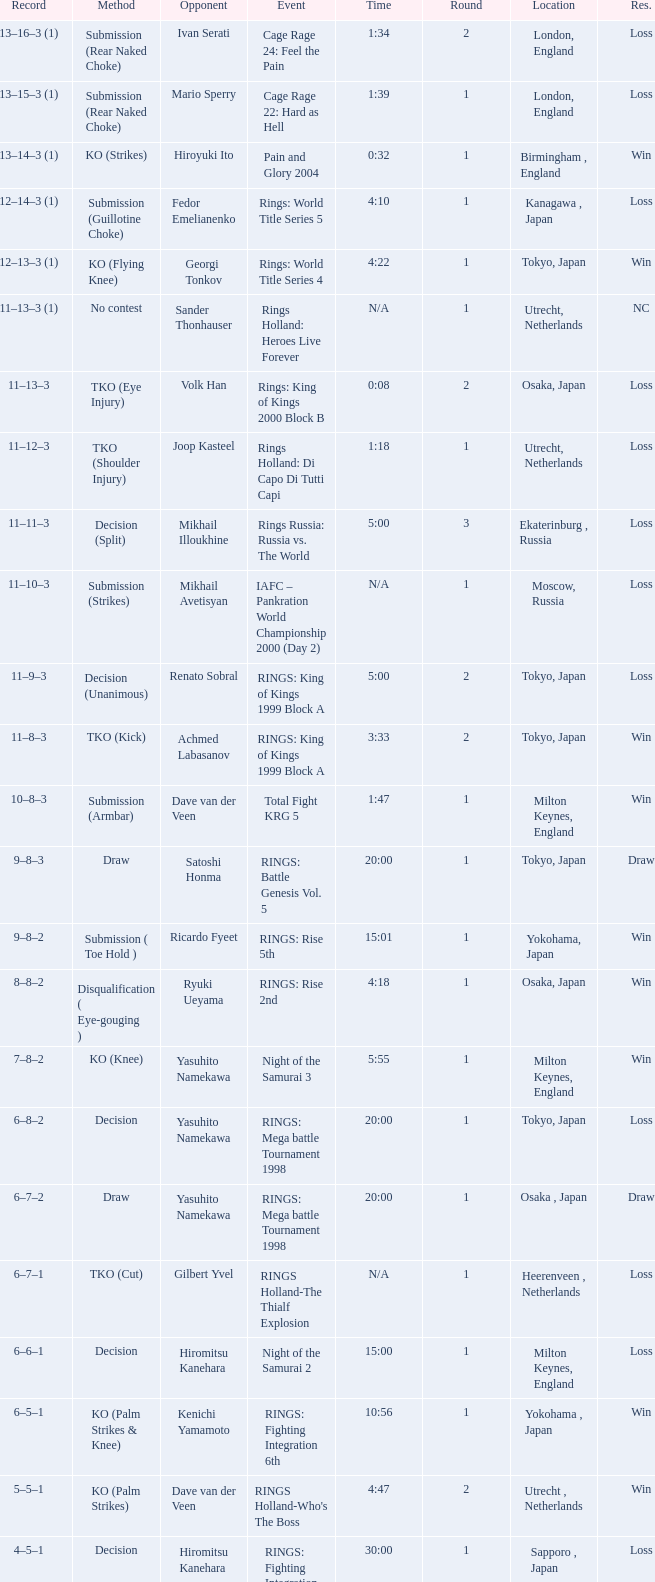Who was the opponent in London, England in a round less than 2? Mario Sperry. 